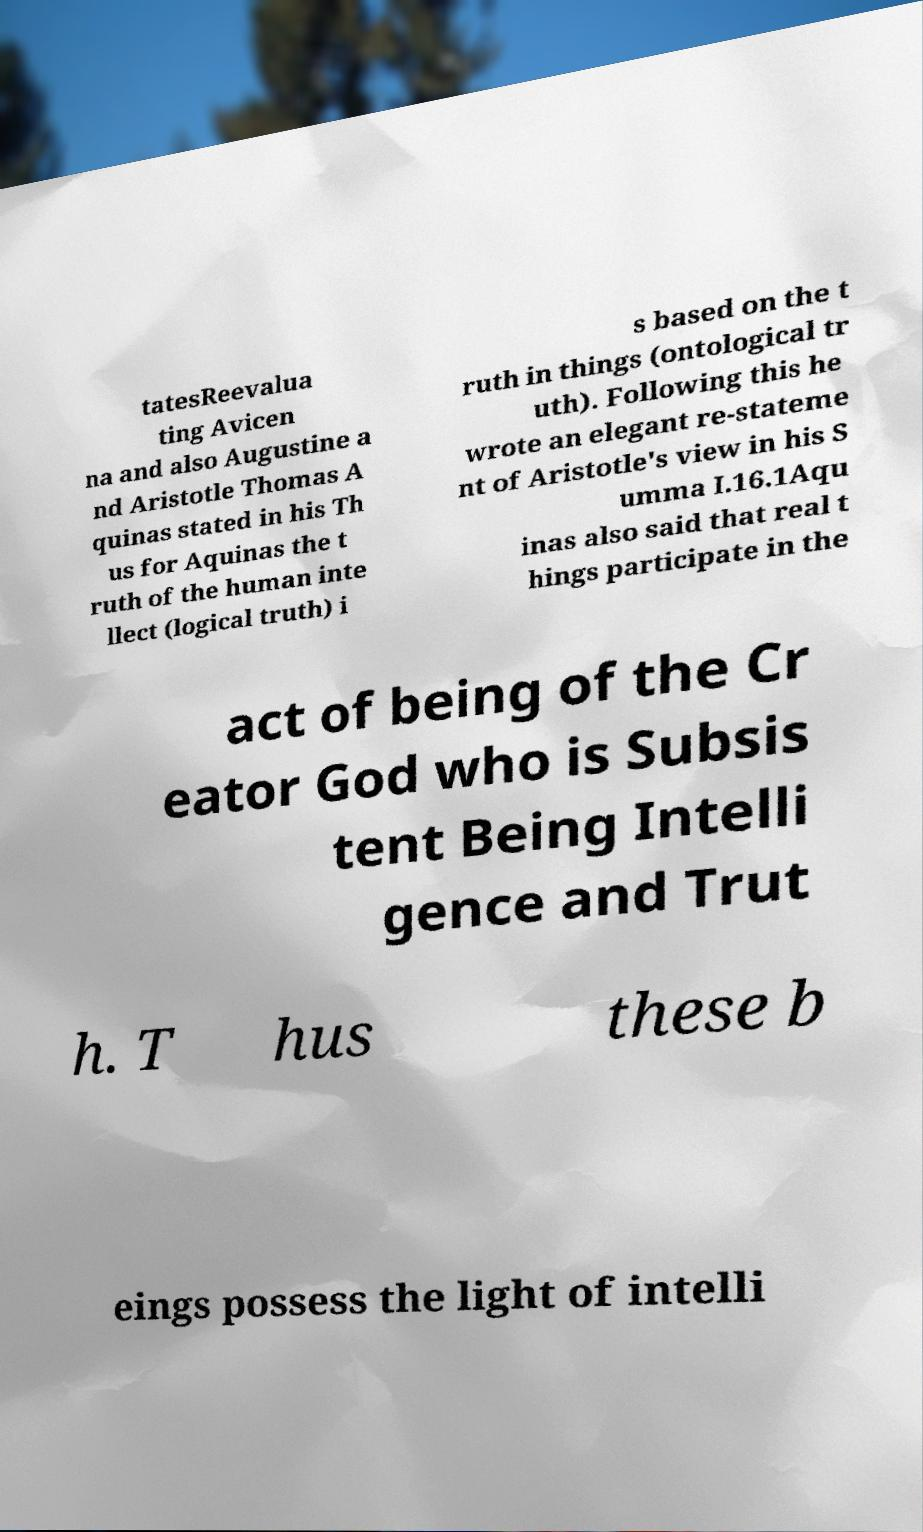Could you extract and type out the text from this image? tatesReevalua ting Avicen na and also Augustine a nd Aristotle Thomas A quinas stated in his Th us for Aquinas the t ruth of the human inte llect (logical truth) i s based on the t ruth in things (ontological tr uth). Following this he wrote an elegant re-stateme nt of Aristotle's view in his S umma I.16.1Aqu inas also said that real t hings participate in the act of being of the Cr eator God who is Subsis tent Being Intelli gence and Trut h. T hus these b eings possess the light of intelli 